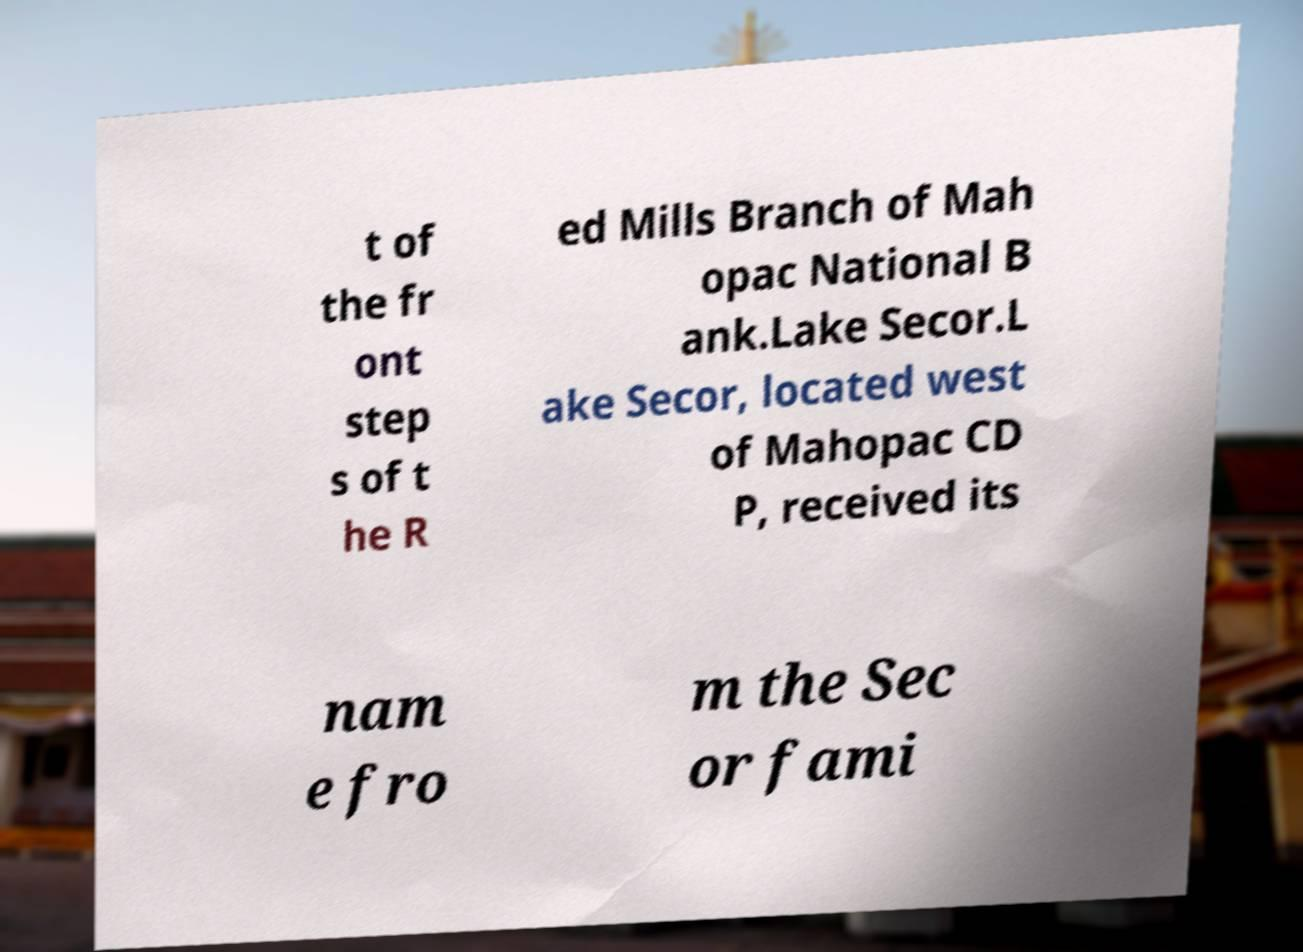Please identify and transcribe the text found in this image. t of the fr ont step s of t he R ed Mills Branch of Mah opac National B ank.Lake Secor.L ake Secor, located west of Mahopac CD P, received its nam e fro m the Sec or fami 